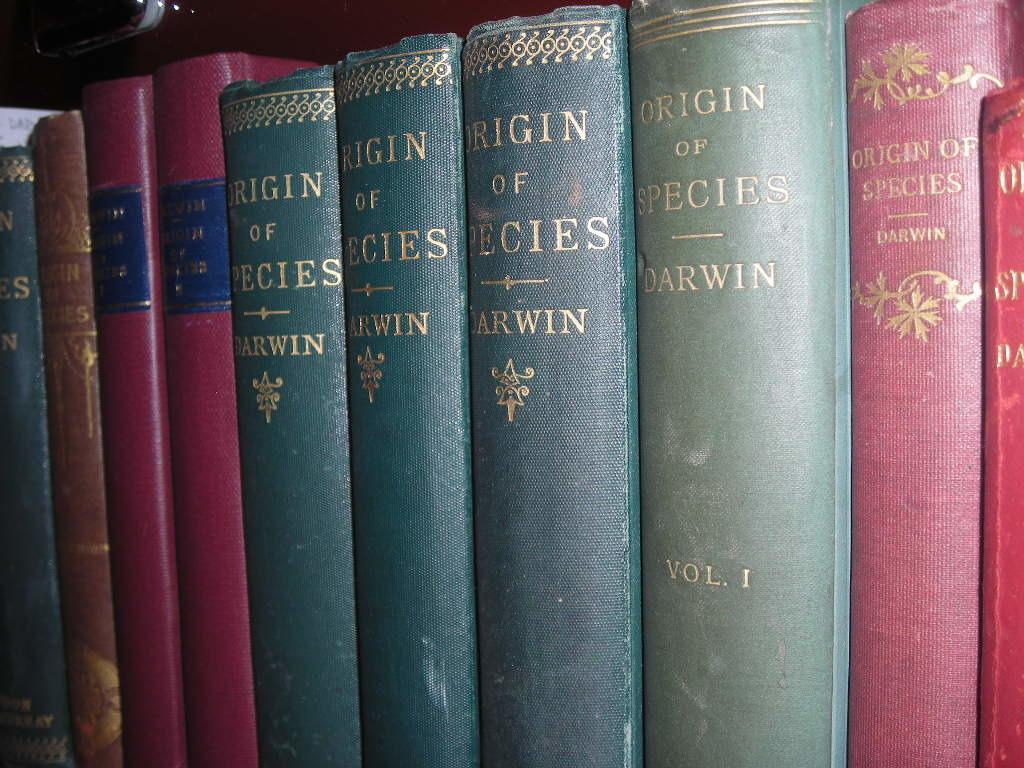<image>
Write a terse but informative summary of the picture. Several books all titled Origin of Species by Darwin are together on a shelf. 